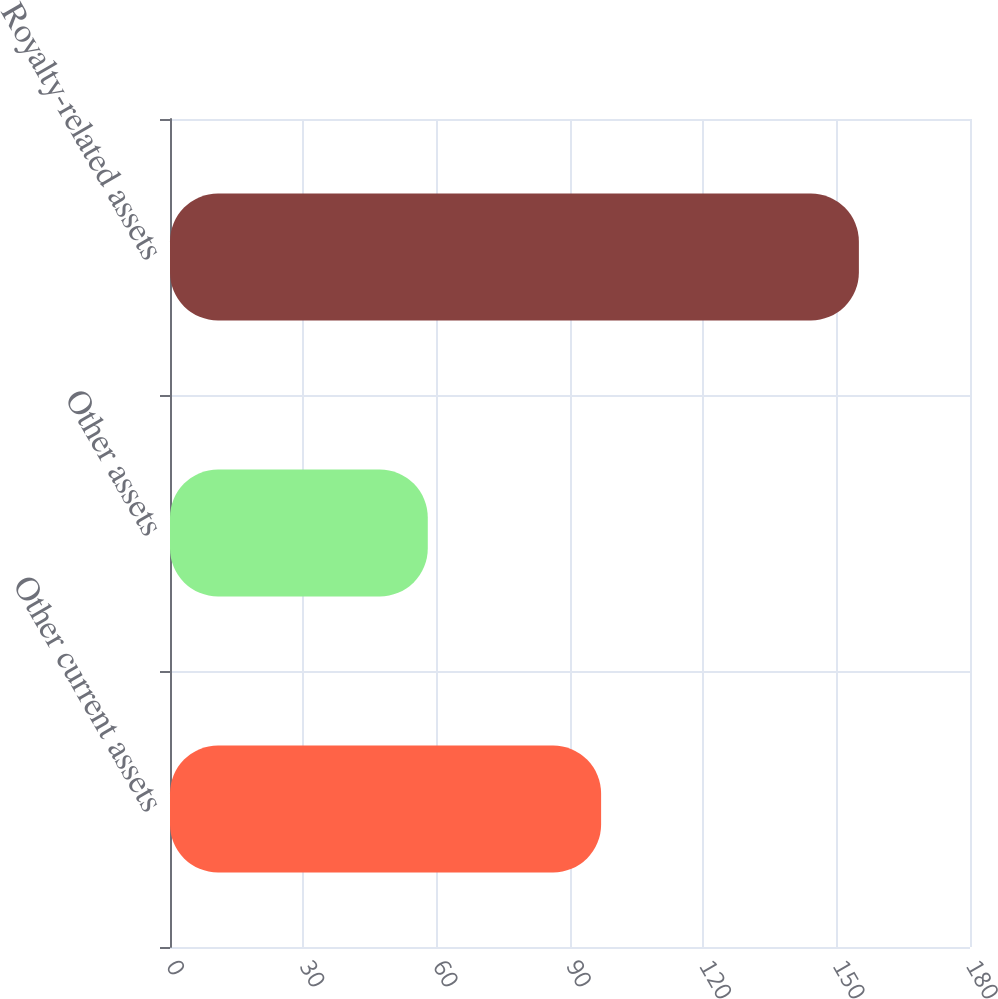Convert chart to OTSL. <chart><loc_0><loc_0><loc_500><loc_500><bar_chart><fcel>Other current assets<fcel>Other assets<fcel>Royalty-related assets<nl><fcel>97<fcel>58<fcel>155<nl></chart> 